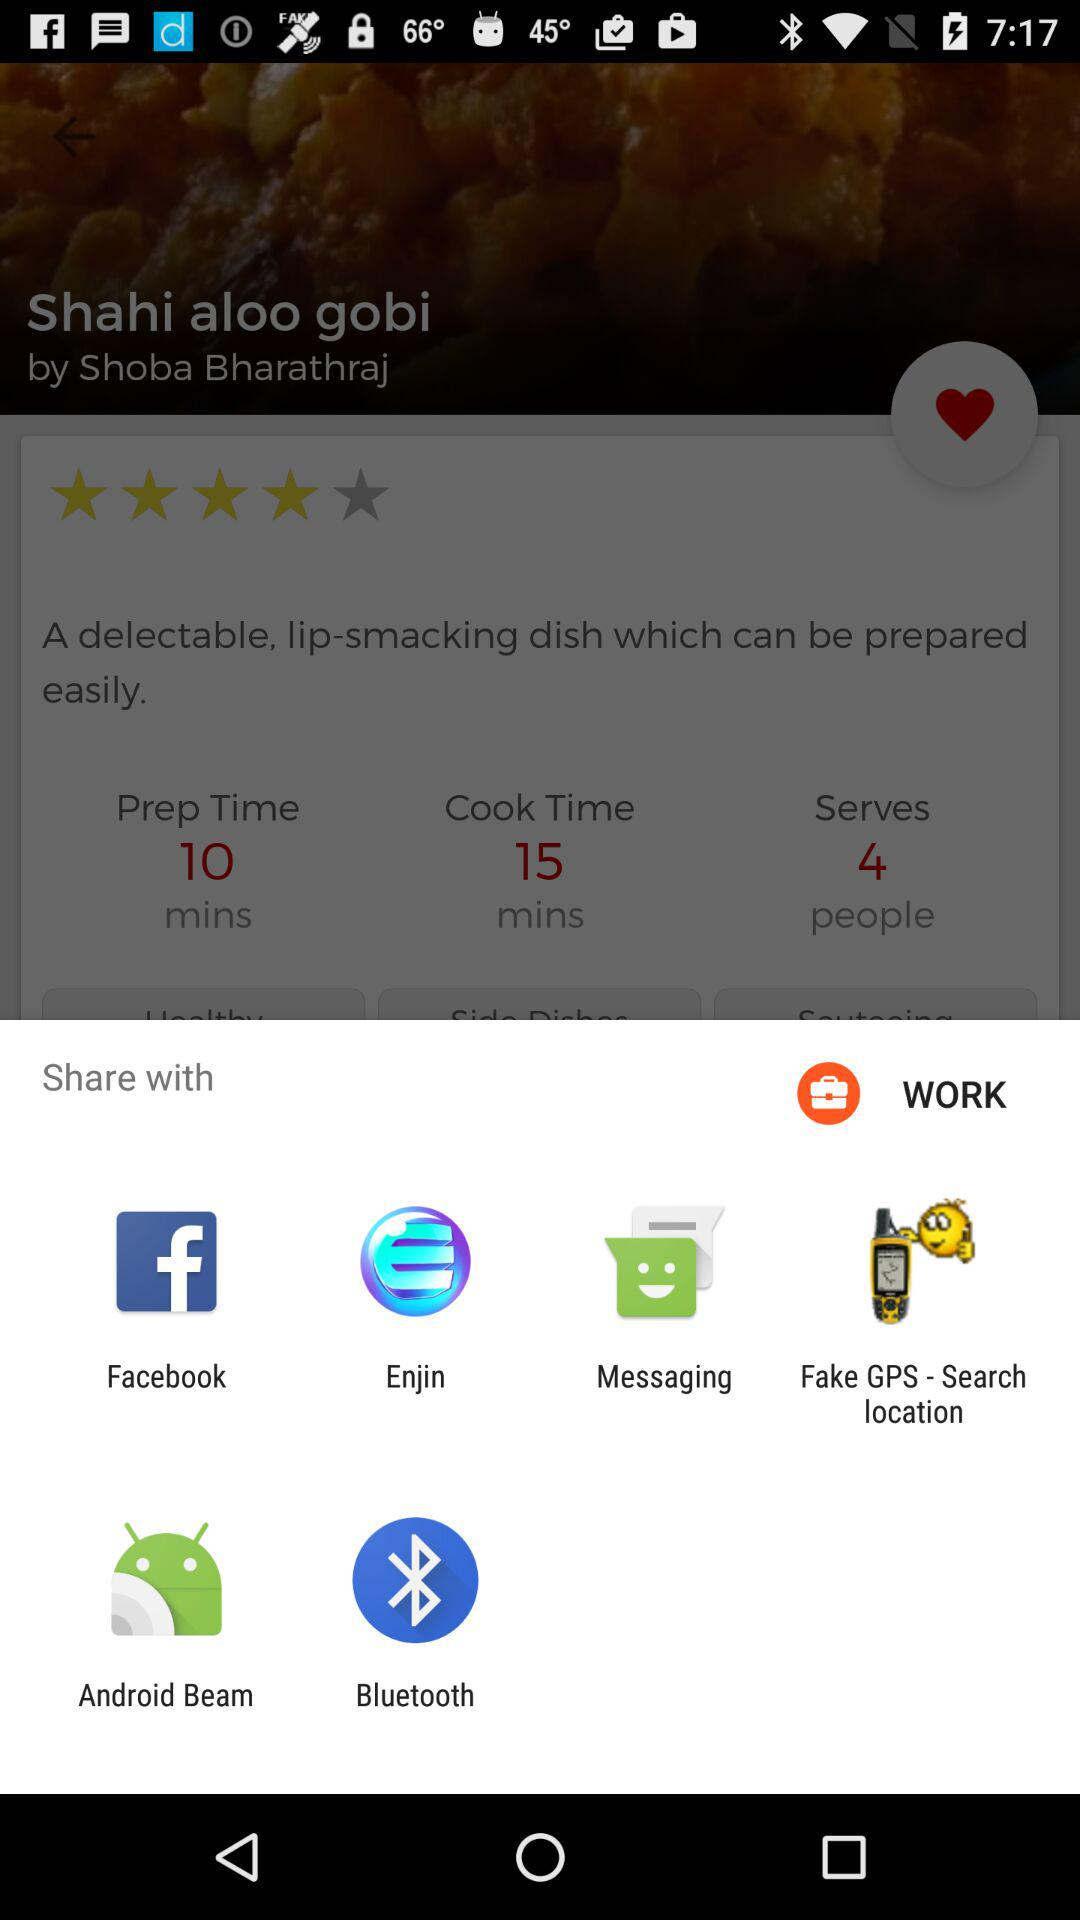What is the cooking time for Shahi aloo gobi? The cooking time is 15 minutes. 